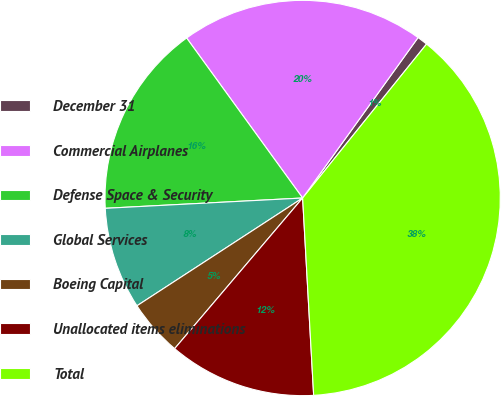Convert chart. <chart><loc_0><loc_0><loc_500><loc_500><pie_chart><fcel>December 31<fcel>Commercial Airplanes<fcel>Defense Space & Security<fcel>Global Services<fcel>Boeing Capital<fcel>Unallocated items eliminations<fcel>Total<nl><fcel>0.86%<fcel>19.91%<fcel>15.85%<fcel>8.35%<fcel>4.61%<fcel>12.1%<fcel>38.33%<nl></chart> 